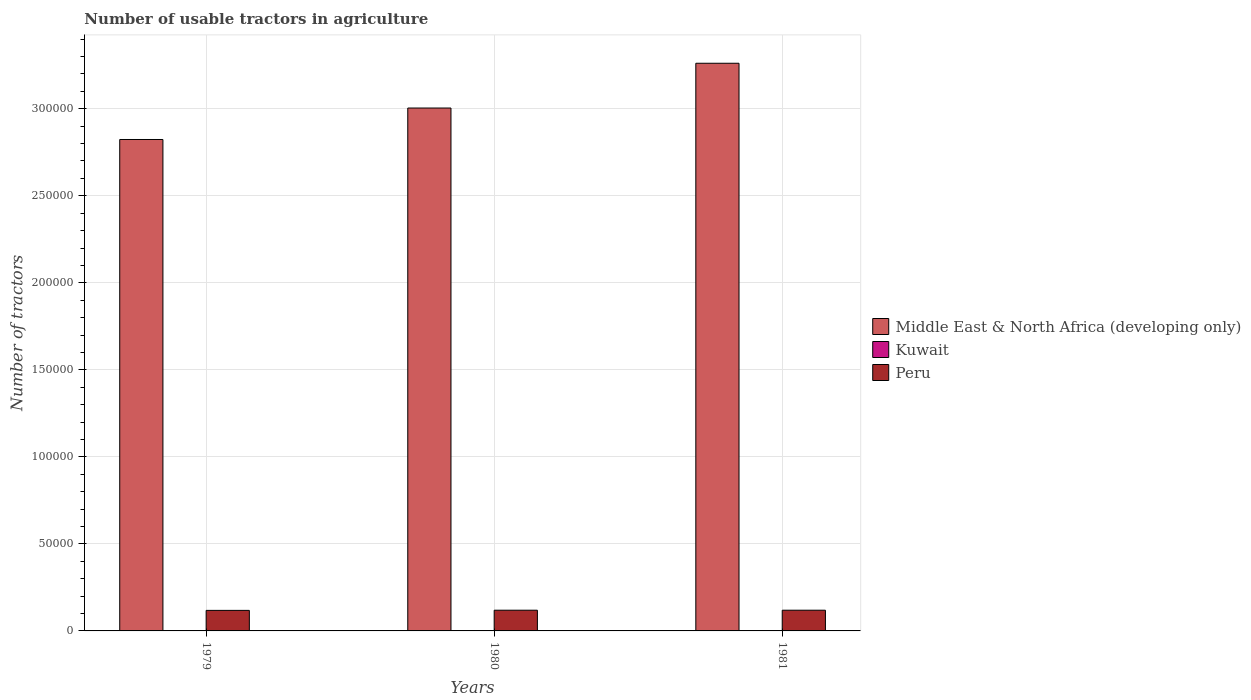How many bars are there on the 3rd tick from the left?
Your response must be concise. 3. What is the label of the 1st group of bars from the left?
Offer a terse response. 1979. In how many cases, is the number of bars for a given year not equal to the number of legend labels?
Give a very brief answer. 0. Across all years, what is the maximum number of usable tractors in agriculture in Middle East & North Africa (developing only)?
Your response must be concise. 3.26e+05. Across all years, what is the minimum number of usable tractors in agriculture in Middle East & North Africa (developing only)?
Provide a short and direct response. 2.82e+05. In which year was the number of usable tractors in agriculture in Kuwait maximum?
Offer a very short reply. 1979. What is the total number of usable tractors in agriculture in Middle East & North Africa (developing only) in the graph?
Ensure brevity in your answer.  9.09e+05. What is the difference between the number of usable tractors in agriculture in Peru in 1979 and that in 1980?
Give a very brief answer. -100. What is the difference between the number of usable tractors in agriculture in Middle East & North Africa (developing only) in 1980 and the number of usable tractors in agriculture in Peru in 1979?
Your answer should be very brief. 2.89e+05. What is the average number of usable tractors in agriculture in Peru per year?
Provide a succinct answer. 1.19e+04. In the year 1980, what is the difference between the number of usable tractors in agriculture in Kuwait and number of usable tractors in agriculture in Peru?
Your answer should be compact. -1.19e+04. In how many years, is the number of usable tractors in agriculture in Kuwait greater than 120000?
Offer a terse response. 0. What is the ratio of the number of usable tractors in agriculture in Middle East & North Africa (developing only) in 1980 to that in 1981?
Give a very brief answer. 0.92. Is the number of usable tractors in agriculture in Middle East & North Africa (developing only) in 1980 less than that in 1981?
Offer a terse response. Yes. Is the difference between the number of usable tractors in agriculture in Kuwait in 1979 and 1980 greater than the difference between the number of usable tractors in agriculture in Peru in 1979 and 1980?
Offer a very short reply. Yes. What is the difference between the highest and the lowest number of usable tractors in agriculture in Peru?
Keep it short and to the point. 100. In how many years, is the number of usable tractors in agriculture in Peru greater than the average number of usable tractors in agriculture in Peru taken over all years?
Provide a short and direct response. 2. What does the 1st bar from the left in 1979 represents?
Make the answer very short. Middle East & North Africa (developing only). What does the 3rd bar from the right in 1981 represents?
Make the answer very short. Middle East & North Africa (developing only). How many years are there in the graph?
Provide a short and direct response. 3. What is the difference between two consecutive major ticks on the Y-axis?
Your response must be concise. 5.00e+04. Are the values on the major ticks of Y-axis written in scientific E-notation?
Your response must be concise. No. Does the graph contain grids?
Your answer should be very brief. Yes. How many legend labels are there?
Your response must be concise. 3. What is the title of the graph?
Your response must be concise. Number of usable tractors in agriculture. Does "Solomon Islands" appear as one of the legend labels in the graph?
Make the answer very short. No. What is the label or title of the Y-axis?
Provide a short and direct response. Number of tractors. What is the Number of tractors of Middle East & North Africa (developing only) in 1979?
Offer a terse response. 2.82e+05. What is the Number of tractors of Peru in 1979?
Provide a short and direct response. 1.18e+04. What is the Number of tractors of Middle East & North Africa (developing only) in 1980?
Your answer should be compact. 3.00e+05. What is the Number of tractors of Peru in 1980?
Keep it short and to the point. 1.19e+04. What is the Number of tractors in Middle East & North Africa (developing only) in 1981?
Give a very brief answer. 3.26e+05. What is the Number of tractors in Peru in 1981?
Give a very brief answer. 1.19e+04. Across all years, what is the maximum Number of tractors in Middle East & North Africa (developing only)?
Provide a short and direct response. 3.26e+05. Across all years, what is the maximum Number of tractors of Peru?
Your answer should be very brief. 1.19e+04. Across all years, what is the minimum Number of tractors of Middle East & North Africa (developing only)?
Ensure brevity in your answer.  2.82e+05. Across all years, what is the minimum Number of tractors in Peru?
Make the answer very short. 1.18e+04. What is the total Number of tractors of Middle East & North Africa (developing only) in the graph?
Your answer should be compact. 9.09e+05. What is the total Number of tractors of Kuwait in the graph?
Provide a short and direct response. 78. What is the total Number of tractors in Peru in the graph?
Make the answer very short. 3.56e+04. What is the difference between the Number of tractors in Middle East & North Africa (developing only) in 1979 and that in 1980?
Your answer should be compact. -1.81e+04. What is the difference between the Number of tractors in Peru in 1979 and that in 1980?
Keep it short and to the point. -100. What is the difference between the Number of tractors of Middle East & North Africa (developing only) in 1979 and that in 1981?
Your answer should be very brief. -4.38e+04. What is the difference between the Number of tractors in Kuwait in 1979 and that in 1981?
Offer a terse response. 5. What is the difference between the Number of tractors of Peru in 1979 and that in 1981?
Give a very brief answer. -100. What is the difference between the Number of tractors of Middle East & North Africa (developing only) in 1980 and that in 1981?
Provide a succinct answer. -2.57e+04. What is the difference between the Number of tractors of Peru in 1980 and that in 1981?
Your answer should be very brief. 0. What is the difference between the Number of tractors of Middle East & North Africa (developing only) in 1979 and the Number of tractors of Kuwait in 1980?
Make the answer very short. 2.82e+05. What is the difference between the Number of tractors in Middle East & North Africa (developing only) in 1979 and the Number of tractors in Peru in 1980?
Give a very brief answer. 2.70e+05. What is the difference between the Number of tractors of Kuwait in 1979 and the Number of tractors of Peru in 1980?
Your answer should be compact. -1.19e+04. What is the difference between the Number of tractors in Middle East & North Africa (developing only) in 1979 and the Number of tractors in Kuwait in 1981?
Your answer should be very brief. 2.82e+05. What is the difference between the Number of tractors in Middle East & North Africa (developing only) in 1979 and the Number of tractors in Peru in 1981?
Give a very brief answer. 2.70e+05. What is the difference between the Number of tractors in Kuwait in 1979 and the Number of tractors in Peru in 1981?
Offer a terse response. -1.19e+04. What is the difference between the Number of tractors in Middle East & North Africa (developing only) in 1980 and the Number of tractors in Kuwait in 1981?
Make the answer very short. 3.00e+05. What is the difference between the Number of tractors of Middle East & North Africa (developing only) in 1980 and the Number of tractors of Peru in 1981?
Keep it short and to the point. 2.89e+05. What is the difference between the Number of tractors of Kuwait in 1980 and the Number of tractors of Peru in 1981?
Your answer should be compact. -1.19e+04. What is the average Number of tractors of Middle East & North Africa (developing only) per year?
Provide a succinct answer. 3.03e+05. What is the average Number of tractors in Kuwait per year?
Offer a terse response. 26. What is the average Number of tractors in Peru per year?
Offer a terse response. 1.19e+04. In the year 1979, what is the difference between the Number of tractors of Middle East & North Africa (developing only) and Number of tractors of Kuwait?
Give a very brief answer. 2.82e+05. In the year 1979, what is the difference between the Number of tractors of Middle East & North Africa (developing only) and Number of tractors of Peru?
Ensure brevity in your answer.  2.71e+05. In the year 1979, what is the difference between the Number of tractors of Kuwait and Number of tractors of Peru?
Your answer should be compact. -1.18e+04. In the year 1980, what is the difference between the Number of tractors of Middle East & North Africa (developing only) and Number of tractors of Kuwait?
Make the answer very short. 3.00e+05. In the year 1980, what is the difference between the Number of tractors of Middle East & North Africa (developing only) and Number of tractors of Peru?
Give a very brief answer. 2.89e+05. In the year 1980, what is the difference between the Number of tractors in Kuwait and Number of tractors in Peru?
Keep it short and to the point. -1.19e+04. In the year 1981, what is the difference between the Number of tractors of Middle East & North Africa (developing only) and Number of tractors of Kuwait?
Keep it short and to the point. 3.26e+05. In the year 1981, what is the difference between the Number of tractors of Middle East & North Africa (developing only) and Number of tractors of Peru?
Your response must be concise. 3.14e+05. In the year 1981, what is the difference between the Number of tractors in Kuwait and Number of tractors in Peru?
Your answer should be very brief. -1.19e+04. What is the ratio of the Number of tractors of Middle East & North Africa (developing only) in 1979 to that in 1980?
Offer a terse response. 0.94. What is the ratio of the Number of tractors of Kuwait in 1979 to that in 1980?
Your answer should be very brief. 1.16. What is the ratio of the Number of tractors of Peru in 1979 to that in 1980?
Provide a succinct answer. 0.99. What is the ratio of the Number of tractors in Middle East & North Africa (developing only) in 1979 to that in 1981?
Your answer should be very brief. 0.87. What is the ratio of the Number of tractors of Kuwait in 1979 to that in 1981?
Keep it short and to the point. 1.21. What is the ratio of the Number of tractors in Peru in 1979 to that in 1981?
Offer a very short reply. 0.99. What is the ratio of the Number of tractors in Middle East & North Africa (developing only) in 1980 to that in 1981?
Provide a short and direct response. 0.92. What is the ratio of the Number of tractors of Kuwait in 1980 to that in 1981?
Offer a terse response. 1.04. What is the difference between the highest and the second highest Number of tractors in Middle East & North Africa (developing only)?
Your answer should be very brief. 2.57e+04. What is the difference between the highest and the second highest Number of tractors of Kuwait?
Your answer should be very brief. 4. What is the difference between the highest and the second highest Number of tractors in Peru?
Give a very brief answer. 0. What is the difference between the highest and the lowest Number of tractors of Middle East & North Africa (developing only)?
Your answer should be very brief. 4.38e+04. 